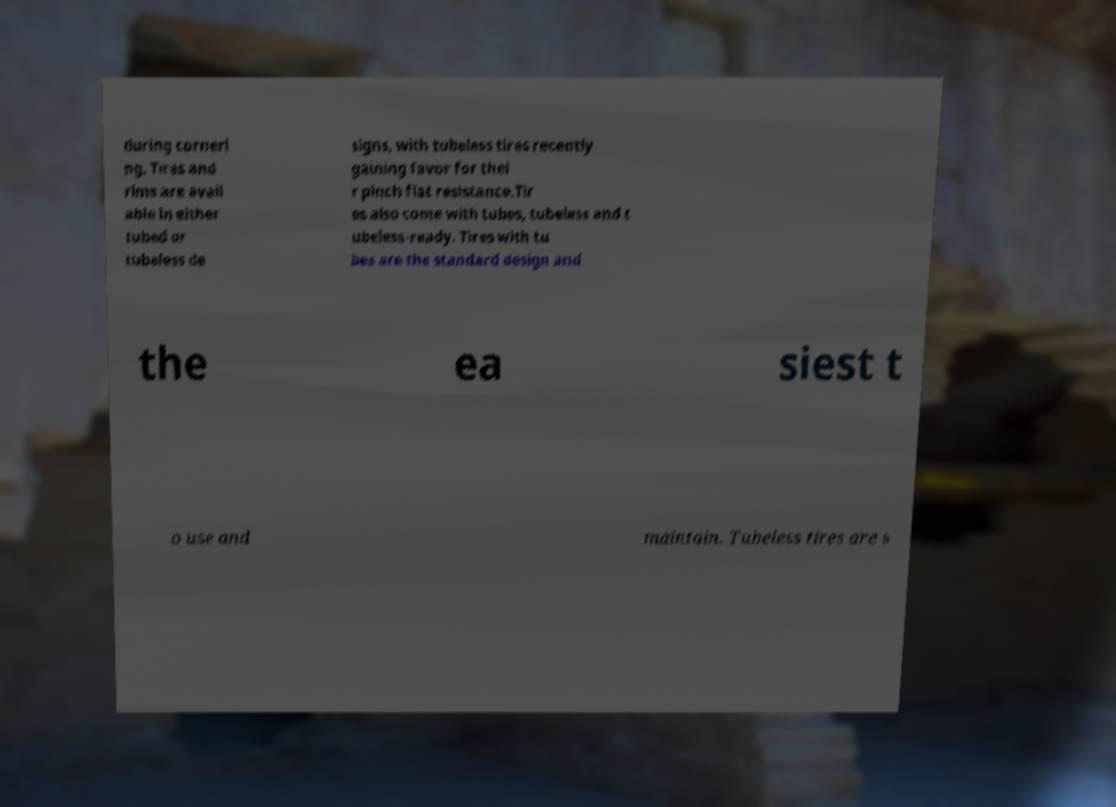Could you assist in decoding the text presented in this image and type it out clearly? during corneri ng. Tires and rims are avail able in either tubed or tubeless de signs, with tubeless tires recently gaining favor for thei r pinch flat resistance.Tir es also come with tubes, tubeless and t ubeless-ready. Tires with tu bes are the standard design and the ea siest t o use and maintain. Tubeless tires are s 